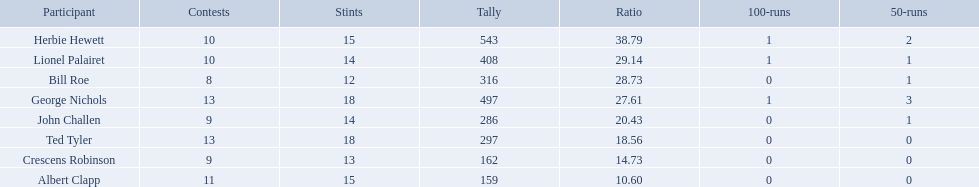Who are the players in somerset county cricket club in 1890? Herbie Hewett, Lionel Palairet, Bill Roe, George Nichols, John Challen, Ted Tyler, Crescens Robinson, Albert Clapp. Who is the only player to play less than 13 innings? Bill Roe. 